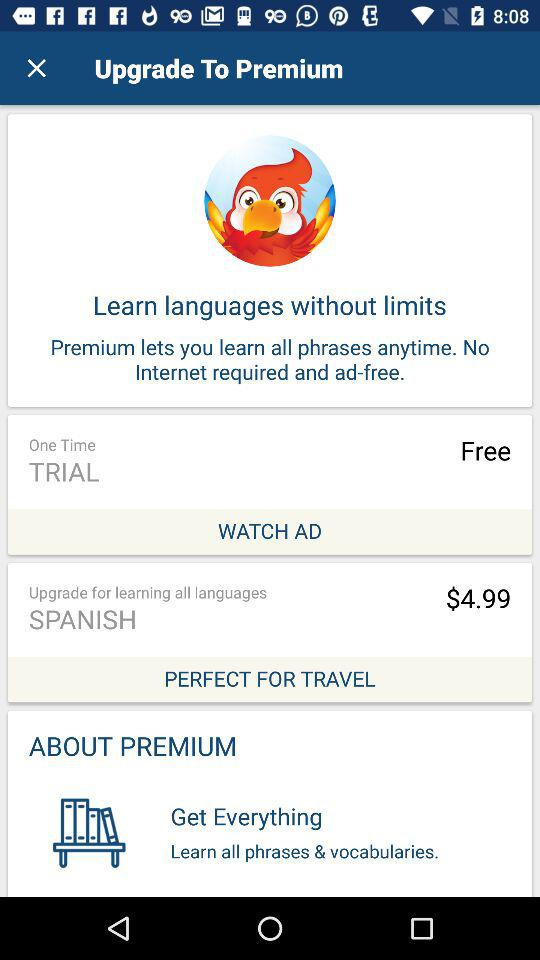What is the price to upgrade for learning all languages? The price to upgrade for learning all languages is $4.99. 